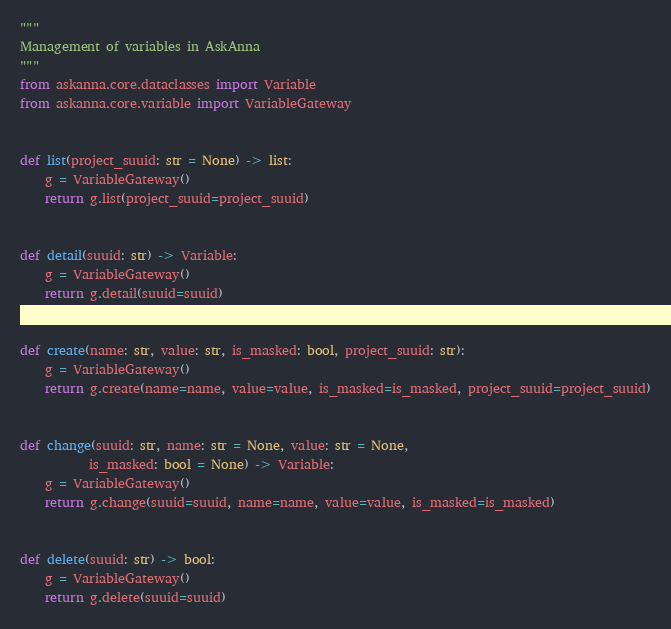Convert code to text. <code><loc_0><loc_0><loc_500><loc_500><_Python_>"""
Management of variables in AskAnna
"""
from askanna.core.dataclasses import Variable
from askanna.core.variable import VariableGateway


def list(project_suuid: str = None) -> list:
    g = VariableGateway()
    return g.list(project_suuid=project_suuid)


def detail(suuid: str) -> Variable:
    g = VariableGateway()
    return g.detail(suuid=suuid)


def create(name: str, value: str, is_masked: bool, project_suuid: str):
    g = VariableGateway()
    return g.create(name=name, value=value, is_masked=is_masked, project_suuid=project_suuid)


def change(suuid: str, name: str = None, value: str = None,
           is_masked: bool = None) -> Variable:
    g = VariableGateway()
    return g.change(suuid=suuid, name=name, value=value, is_masked=is_masked)


def delete(suuid: str) -> bool:
    g = VariableGateway()
    return g.delete(suuid=suuid)
</code> 